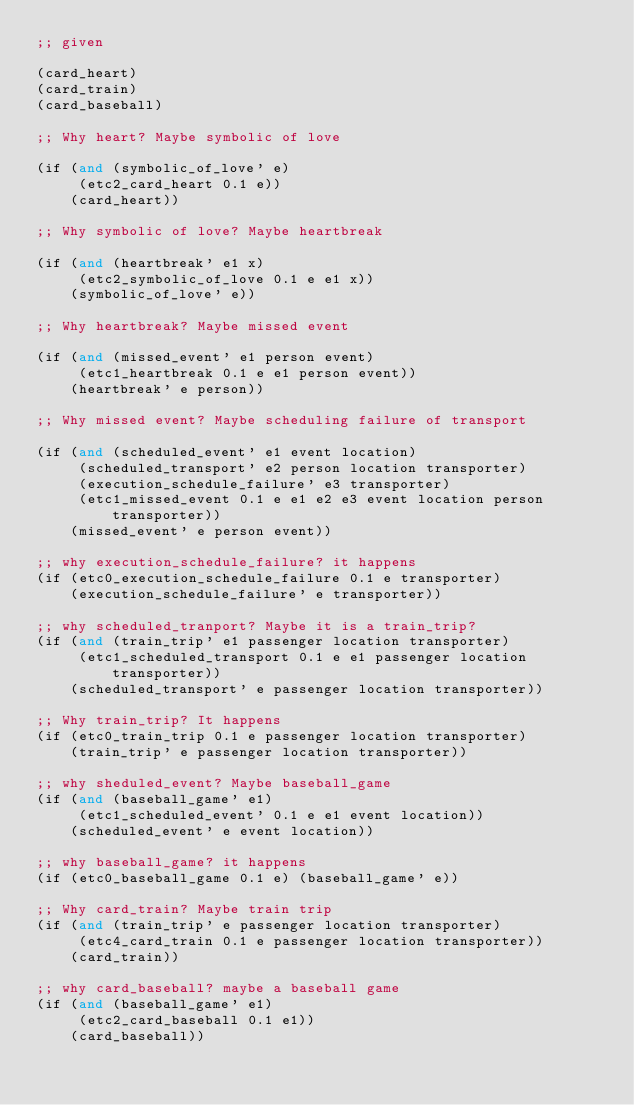Convert code to text. <code><loc_0><loc_0><loc_500><loc_500><_Lisp_>;; given

(card_heart)
(card_train)
(card_baseball)

;; Why heart? Maybe symbolic of love

(if (and (symbolic_of_love' e)
	 (etc2_card_heart 0.1 e))
    (card_heart))

;; Why symbolic of love? Maybe heartbreak

(if (and (heartbreak' e1 x)
	 (etc2_symbolic_of_love 0.1 e e1 x))
    (symbolic_of_love' e))

;; Why heartbreak? Maybe missed event

(if (and (missed_event' e1 person event)
	 (etc1_heartbreak 0.1 e e1 person event))
    (heartbreak' e person))

;; Why missed event? Maybe scheduling failure of transport

(if (and (scheduled_event' e1 event location)
	 (scheduled_transport' e2 person location transporter)
	 (execution_schedule_failure' e3 transporter)
	 (etc1_missed_event 0.1 e e1 e2 e3 event location person transporter))
    (missed_event' e person event))

;; why execution_schedule_failure? it happens
(if (etc0_execution_schedule_failure 0.1 e transporter)
    (execution_schedule_failure' e transporter))

;; why scheduled_tranport? Maybe it is a train_trip?
(if (and (train_trip' e1 passenger location transporter)
	 (etc1_scheduled_transport 0.1 e e1 passenger location transporter))
    (scheduled_transport' e passenger location transporter))

;; Why train_trip? It happens
(if (etc0_train_trip 0.1 e passenger location transporter)
    (train_trip' e passenger location transporter))

;; why sheduled_event? Maybe baseball_game
(if (and (baseball_game' e1)
	 (etc1_scheduled_event' 0.1 e e1 event location))
    (scheduled_event' e event location))

;; why baseball_game? it happens
(if (etc0_baseball_game 0.1 e) (baseball_game' e))

;; Why card_train? Maybe train trip
(if (and (train_trip' e passenger location transporter)
	 (etc4_card_train 0.1 e passenger location transporter))
    (card_train))

;; why card_baseball? maybe a baseball game
(if (and (baseball_game' e1)
	 (etc2_card_baseball 0.1 e1))
    (card_baseball))
   
</code> 